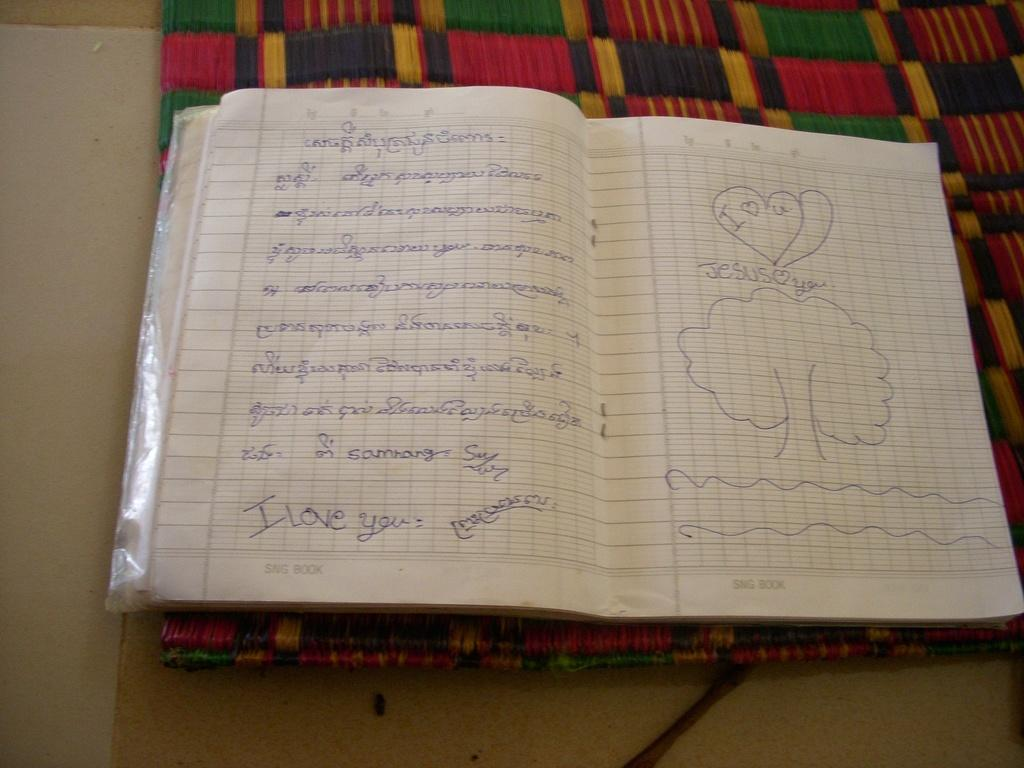<image>
Write a terse but informative summary of the picture. A student's sketchbook with writing and a picture that reads JESUS <3 YOU. 